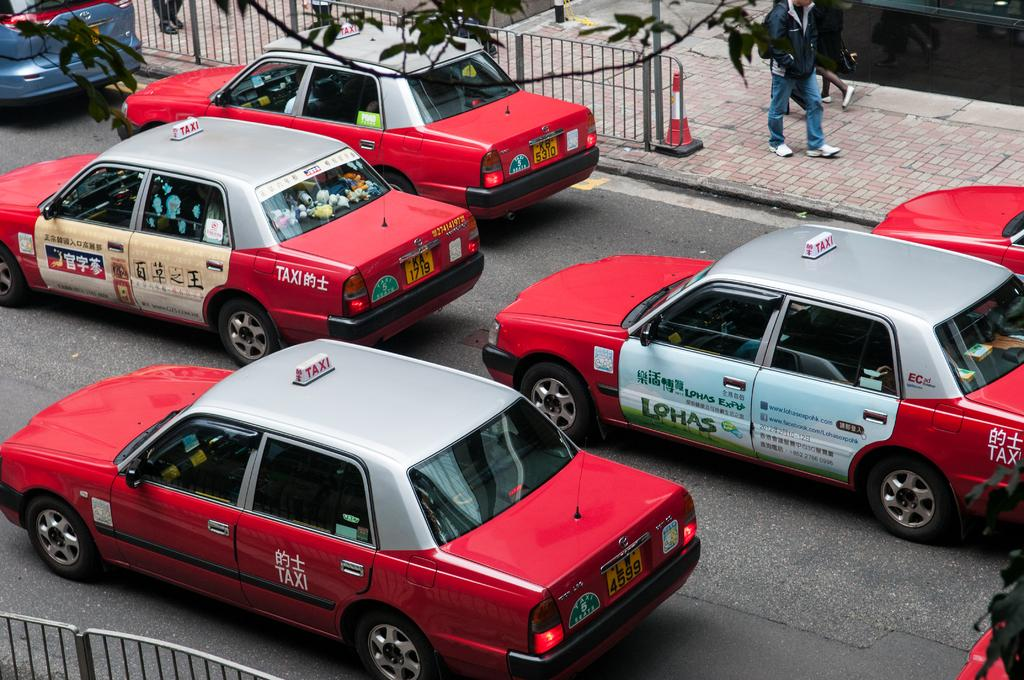<image>
Describe the image concisely. A row of red and silver cars are lined up in the street and one has an ad that says Lohas on the side. 